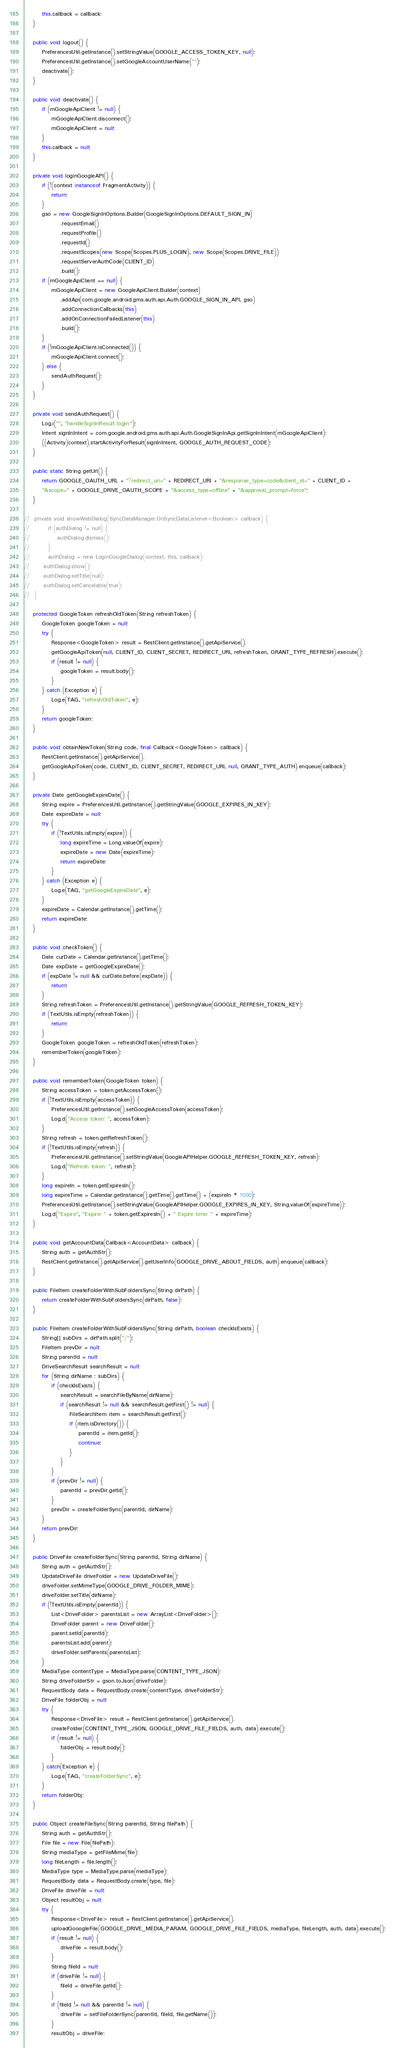Convert code to text. <code><loc_0><loc_0><loc_500><loc_500><_Java_>        this.callback = callback;
	}
	
	public void logout() {
        PreferencesUtil.getInstance().setStringValue(GOOGLE_ACCESS_TOKEN_KEY, null);
        PreferencesUtil.getInstance().setGoogleAccountUserName("");
        deactivate();
    }

    public void deactivate() {
        if (mGoogleApiClient != null) {
            mGoogleApiClient.disconnect();
            mGoogleApiClient = null;
        }
        this.callback = null;
    }

	private void loginGoogleAPI() {
        if (!(context instanceof FragmentActivity)) {
            return;
        }
        gso = new GoogleSignInOptions.Builder(GoogleSignInOptions.DEFAULT_SIGN_IN)
                .requestEmail()
                .requestProfile()
                .requestId()
                .requestScopes(new Scope(Scopes.PLUS_LOGIN), new Scope(Scopes.DRIVE_FILE))
                .requestServerAuthCode(CLIENT_ID)
                .build();
        if (mGoogleApiClient == null) {
            mGoogleApiClient = new GoogleApiClient.Builder(context)
                .addApi(com.google.android.gms.auth.api.Auth.GOOGLE_SIGN_IN_API, gso)
                .addConnectionCallbacks(this)
                .addOnConnectionFailedListener(this)
                .build();
        }
        if (!mGoogleApiClient.isConnected()) {
            mGoogleApiClient.connect();
        } else {
            sendAuthRequest();
        }
    }

    private void sendAuthRequest() {
        Log.i("", "handleSignInResult login:");
        Intent signInIntent = com.google.android.gms.auth.api.Auth.GoogleSignInApi.getSignInIntent(mGoogleApiClient);
        ((Activity)context).startActivityForResult(signInIntent, GOOGLE_AUTH_REQUEST_CODE);
    }

	public static String getUrl() {
		return GOOGLE_OAUTH_URL + "?redirect_uri=" + REDIRECT_URI + "&response_type=code&client_id=" + CLIENT_ID +
        "&scope=" + GOOGLE_DRIVE_OAUTH_SCOPE + "&access_type=offline" + "&approval_prompt=force";
	}

//	private void showWebDialog(SyncDataManager.OnSyncDataListener<Boolean> callback) {
//        if (authDialog != null) {
//            authDialog.dismiss();
//        }
//        authDialog = new LoginGoogleDialog(context, this, callback);
//		authDialog.show();
//		authDialog.setTitle(null);
//		authDialog.setCancelable(true);
//	}

	protected GoogleToken refreshOldToken(String refreshToken) {
        GoogleToken googleToken = null;
        try {
            Response<GoogleToken> result = RestClient.getInstance().getApiService().
            getGoogleApiToken(null, CLIENT_ID, CLIENT_SECRET, REDIRECT_URI, refreshToken, GRANT_TYPE_REFRESH).execute();
            if (result != null) {
                googleToken = result.body();
            }
        } catch (Exception e) {
            Log.e(TAG, "refreshOldToken", e);
        }
        return googleToken;
	}

    public void obtainNewToken(String code, final Callback<GoogleToken> callback) {
        RestClient.getInstance().getApiService().
        getGoogleApiToken(code, CLIENT_ID, CLIENT_SECRET, REDIRECT_URI, null, GRANT_TYPE_AUTH).enqueue(callback);
    }

	private Date getGoogleExpireDate() {
		String expire = PreferencesUtil.getInstance().getStringValue(GOOGLE_EXPIRES_IN_KEY);
		Date expireDate = null;
		try {
			if (!TextUtils.isEmpty(expire)) {
				long expireTime = Long.valueOf(expire);
				expireDate = new Date(expireTime);
				return expireDate;
			}
		} catch (Exception e) {
            Log.e(TAG, "getGoogleExpireDate", e);
        }
		expireDate = Calendar.getInstance().getTime();
		return expireDate;
	}

	public void checkToken() {
		Date curDate = Calendar.getInstance().getTime();
		Date expDate = getGoogleExpireDate();
		if (expDate != null && curDate.before(expDate)) {
			return;
		}
		String refreshToken = PreferencesUtil.getInstance().getStringValue(GOOGLE_REFRESH_TOKEN_KEY);
		if (TextUtils.isEmpty(refreshToken)) {
			return;
		}
        GoogleToken googleToken = refreshOldToken(refreshToken);
        rememberToken(googleToken);
	}

    public void rememberToken(GoogleToken token) {
        String accessToken = token.getAccessToken();
        if (!TextUtils.isEmpty(accessToken)) {
            PreferencesUtil.getInstance().setGoogleAccessToken(accessToken);
            Log.d("Access token: ", accessToken);
        }
        String refresh = token.getRefreshToken();
        if (!TextUtils.isEmpty(refresh)) {
            PreferencesUtil.getInstance().setStringValue(GoogleAPIHelper.GOOGLE_REFRESH_TOKEN_KEY, refresh);
            Log.d("Refresh token: ", refresh);
        }
        long expireIn = token.getExpiresIn();
        long expireTime = Calendar.getInstance().getTime().getTime() + (expireIn * 1000);
        PreferencesUtil.getInstance().setStringValue(GoogleAPIHelper.GOOGLE_EXPIRES_IN_KEY, String.valueOf(expireTime));
        Log.d("Expire", "Expire: " + token.getExpiresIn() + " Expire time: " + expireTime);
    }

    public void getAccountData(Callback<AccountData> callback) {
        String auth = getAuthStr();
        RestClient.getInstance().getApiService().getUserInfo(GOOGLE_DRIVE_ABOUT_FIELDS, auth).enqueue(callback);
    }

    public FileItem createFolderWithSubFoldersSync(String dirPath) {
        return createFolderWithSubFoldersSync(dirPath, false);
    }

    public FileItem createFolderWithSubFoldersSync(String dirPath, boolean checkIsExists) {
        String[] subDirs = dirPath.split("/");
        FileItem prevDir = null;
        String parentId = null;
        DriveSearchResult searchResult = null;
        for (String dirName : subDirs) {
            if (checkIsExists) {
                searchResult = searchFileByName(dirName);
                if (searchResult != null && searchResult.getFirst() != null) {
                    FileSearchItem item = searchResult.getFirst();
                    if (item.isDirectory()) {
                        parentId = item.getId();
                        continue;
                    }
                }
            }
            if (prevDir != null) {
                parentId = prevDir.getId();
            }
            prevDir = createFolderSync(parentId, dirName);
        }
        return prevDir;
    }

    public DriveFile createFolderSync(String parentId, String dirName) {
        String auth = getAuthStr();
        UpdateDriveFile driveFolder = new UpdateDriveFile();
        driveFolder.setMimeType(GOOGLE_DRIVE_FOLDER_MIME);
        driveFolder.setTitle(dirName);
        if (!TextUtils.isEmpty(parentId)) {
            List<DriveFolder> parentsList = new ArrayList<DriveFolder>();
            DriveFolder parent = new DriveFolder();
            parent.setId(parentId);
            parentsList.add(parent);
            driveFolder.setParents(parentsList);
        }
        MediaType contentType = MediaType.parse(CONTENT_TYPE_JSON);
        String driveFolderStr = gson.toJson(driveFolder);
        RequestBody data = RequestBody.create(contentType, driveFolderStr);
        DriveFile folderObj = null;
        try {
            Response<DriveFile> result = RestClient.getInstance().getApiService().
            createFolder(CONTENT_TYPE_JSON, GOOGLE_DRIVE_FILE_FIELDS, auth, data).execute();
            if (result != null) {
                folderObj = result.body();
            }
        } catch(Exception e) {
            Log.e(TAG, "createFolderSync", e);
        }
        return folderObj;
    }

    public Object createFileSync(String parentId, String filePath) {
        String auth = getAuthStr();
        File file = new File(filePath);
        String mediaType = getFileMime(file);
        long fileLength = file.length();
        MediaType type = MediaType.parse(mediaType);
        RequestBody data = RequestBody.create(type, file);
        DriveFile driveFile = null;
        Object resultObj = null;
        try {
            Response<DriveFile> result = RestClient.getInstance().getApiService().
            uploadGooogleFile(GOOGLE_DRIVE_MEDIA_PARAM, GOOGLE_DRIVE_FILE_FIELDS, mediaType, fileLength, auth, data).execute();
            if (result != null) {
                driveFile = result.body();
            }
            String fileId = null;
            if (driveFile != null) {
                fileId = driveFile.getId();
            }
            if (fileId != null && parentId != null) {
                driveFile = setFileFolderSync(parentId, fileId, file.getName());
            }
            resultObj = driveFile;</code> 